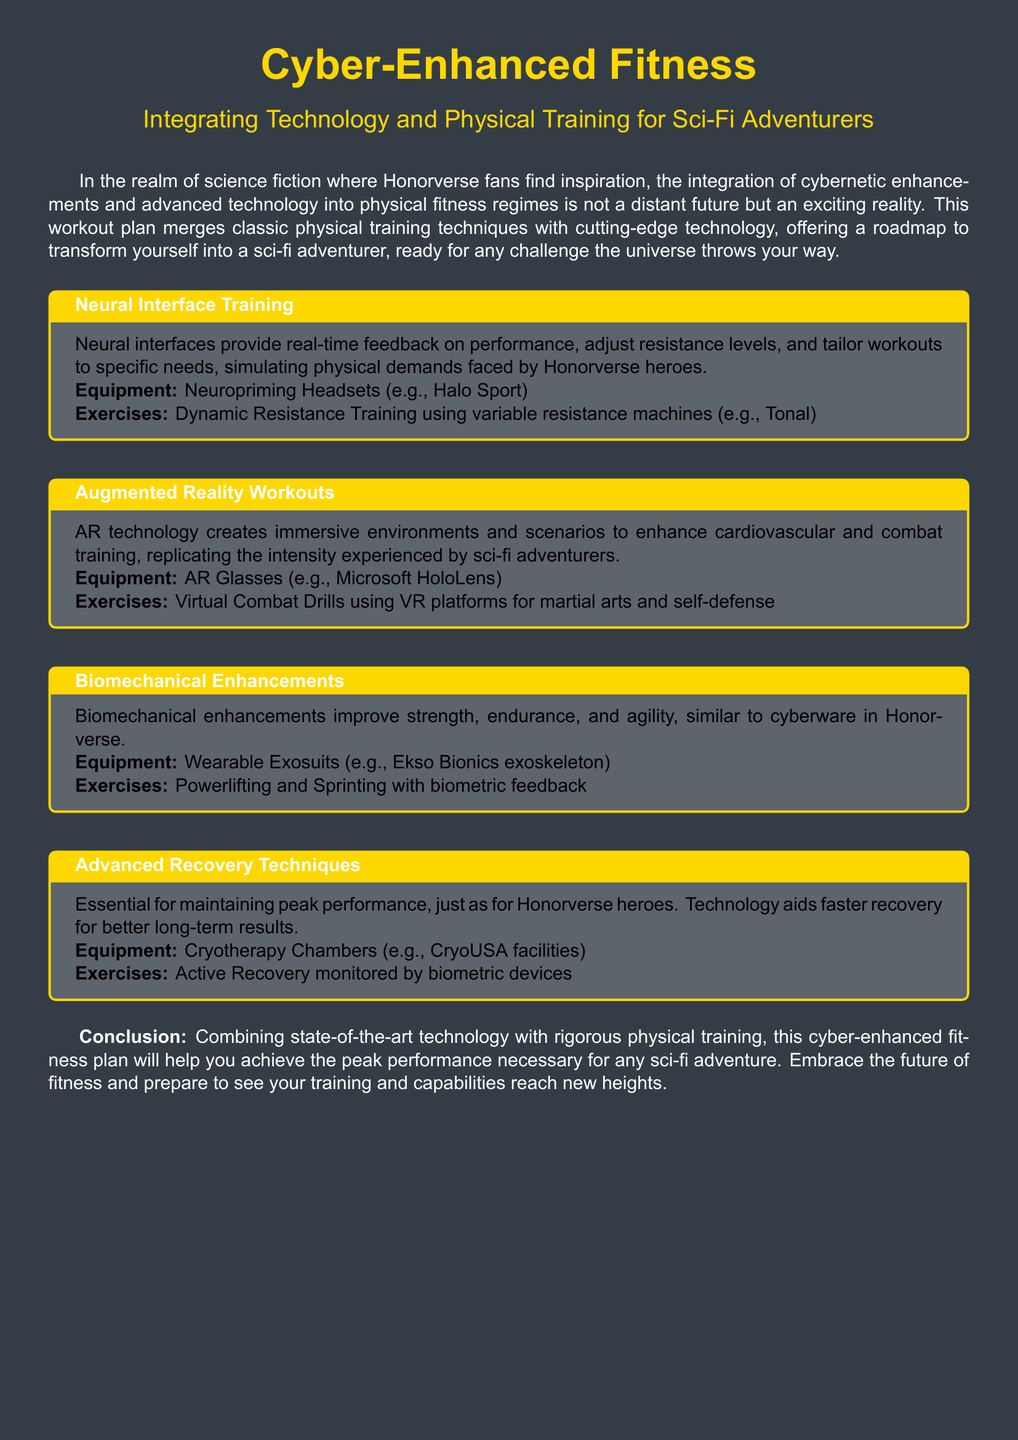What is the title of the workout plan? The title is prominently displayed at the top of the document, identifying the subject matter.
Answer: Cyber-Enhanced Fitness What technology is suggested for Neural Interface Training? The document specifies the equipment needed for this training type, which helps in real-time performance feedback.
Answer: Neuropriming Headsets What type of exercises are recommended for Augmented Reality Workouts? The document outlines specific exercises that leverage augmented reality technology for training.
Answer: Virtual Combat Drills What equipment is associated with Biomechanical Enhancements? The document lists a specific type of wearable technology that improves strength and agility.
Answer: Wearable Exosuits What recovery technique is highlighted in the workout plan? The document emphasizes the importance of recovery technology for peak performance.
Answer: Cryotherapy Chambers Which exercise type is paired with Advanced Recovery Techniques? The document indicates a specific activity monitored via biometric devices that aids recovery.
Answer: Active Recovery How do Neural Interfaces benefit training? The document explains how they adjust workouts and provide real-time feedback, simulating challenges faced in training.
Answer: Real-time feedback What is the primary goal of the Cyber-Enhanced Fitness plan? The document concludes with the aim of merging technology and physical training for enhanced performance.
Answer: Peak performance 